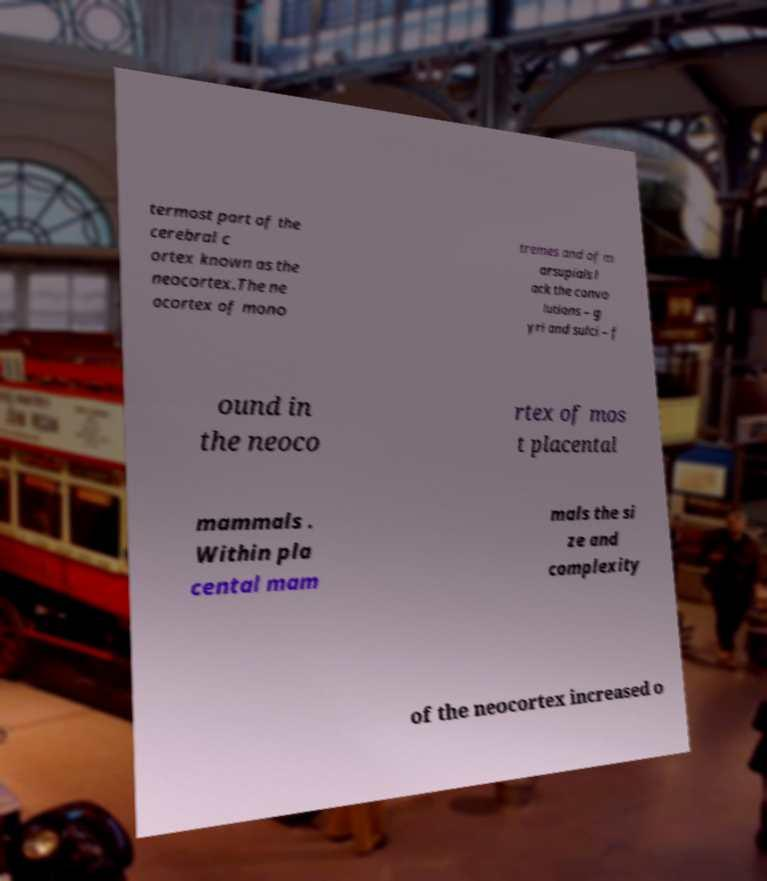What messages or text are displayed in this image? I need them in a readable, typed format. termost part of the cerebral c ortex known as the neocortex.The ne ocortex of mono tremes and of m arsupials l ack the convo lutions – g yri and sulci – f ound in the neoco rtex of mos t placental mammals . Within pla cental mam mals the si ze and complexity of the neocortex increased o 